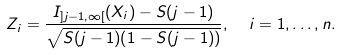Convert formula to latex. <formula><loc_0><loc_0><loc_500><loc_500>Z _ { i } = \frac { I _ { ] j - 1 , \infty [ } ( X _ { i } ) - S ( j - 1 ) } { \sqrt { S ( j - 1 ) ( 1 - S ( j - 1 ) ) } } , \ \ i = 1 , \dots , n .</formula> 